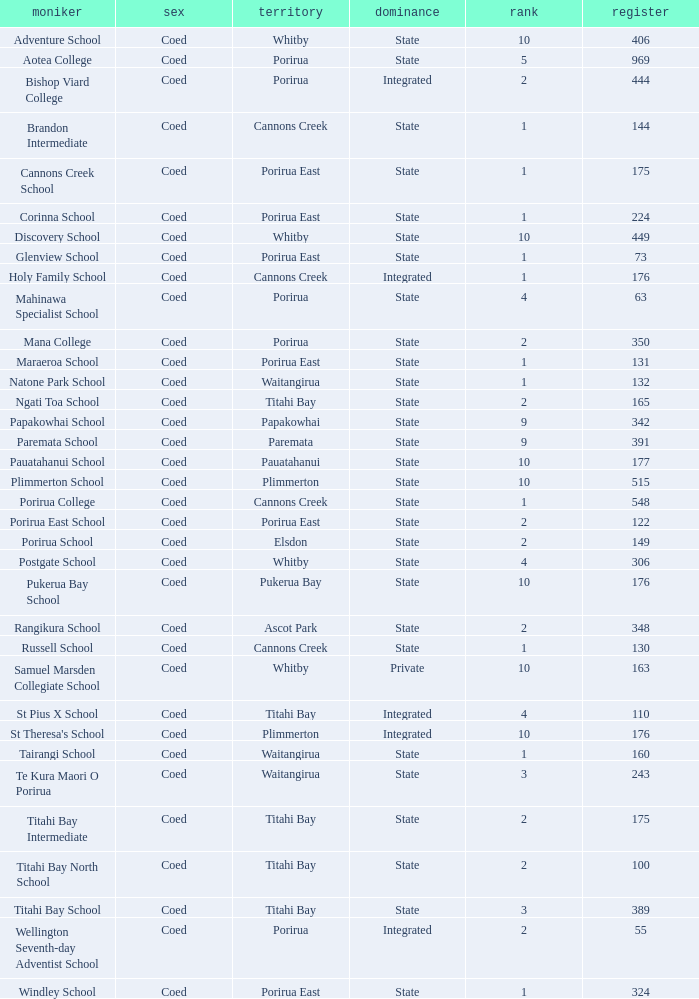What is the roll of Bishop Viard College (An Integrated College), which has a decile larger than 1? 1.0. Give me the full table as a dictionary. {'header': ['moniker', 'sex', 'territory', 'dominance', 'rank', 'register'], 'rows': [['Adventure School', 'Coed', 'Whitby', 'State', '10', '406'], ['Aotea College', 'Coed', 'Porirua', 'State', '5', '969'], ['Bishop Viard College', 'Coed', 'Porirua', 'Integrated', '2', '444'], ['Brandon Intermediate', 'Coed', 'Cannons Creek', 'State', '1', '144'], ['Cannons Creek School', 'Coed', 'Porirua East', 'State', '1', '175'], ['Corinna School', 'Coed', 'Porirua East', 'State', '1', '224'], ['Discovery School', 'Coed', 'Whitby', 'State', '10', '449'], ['Glenview School', 'Coed', 'Porirua East', 'State', '1', '73'], ['Holy Family School', 'Coed', 'Cannons Creek', 'Integrated', '1', '176'], ['Mahinawa Specialist School', 'Coed', 'Porirua', 'State', '4', '63'], ['Mana College', 'Coed', 'Porirua', 'State', '2', '350'], ['Maraeroa School', 'Coed', 'Porirua East', 'State', '1', '131'], ['Natone Park School', 'Coed', 'Waitangirua', 'State', '1', '132'], ['Ngati Toa School', 'Coed', 'Titahi Bay', 'State', '2', '165'], ['Papakowhai School', 'Coed', 'Papakowhai', 'State', '9', '342'], ['Paremata School', 'Coed', 'Paremata', 'State', '9', '391'], ['Pauatahanui School', 'Coed', 'Pauatahanui', 'State', '10', '177'], ['Plimmerton School', 'Coed', 'Plimmerton', 'State', '10', '515'], ['Porirua College', 'Coed', 'Cannons Creek', 'State', '1', '548'], ['Porirua East School', 'Coed', 'Porirua East', 'State', '2', '122'], ['Porirua School', 'Coed', 'Elsdon', 'State', '2', '149'], ['Postgate School', 'Coed', 'Whitby', 'State', '4', '306'], ['Pukerua Bay School', 'Coed', 'Pukerua Bay', 'State', '10', '176'], ['Rangikura School', 'Coed', 'Ascot Park', 'State', '2', '348'], ['Russell School', 'Coed', 'Cannons Creek', 'State', '1', '130'], ['Samuel Marsden Collegiate School', 'Coed', 'Whitby', 'Private', '10', '163'], ['St Pius X School', 'Coed', 'Titahi Bay', 'Integrated', '4', '110'], ["St Theresa's School", 'Coed', 'Plimmerton', 'Integrated', '10', '176'], ['Tairangi School', 'Coed', 'Waitangirua', 'State', '1', '160'], ['Te Kura Maori O Porirua', 'Coed', 'Waitangirua', 'State', '3', '243'], ['Titahi Bay Intermediate', 'Coed', 'Titahi Bay', 'State', '2', '175'], ['Titahi Bay North School', 'Coed', 'Titahi Bay', 'State', '2', '100'], ['Titahi Bay School', 'Coed', 'Titahi Bay', 'State', '3', '389'], ['Wellington Seventh-day Adventist School', 'Coed', 'Porirua', 'Integrated', '2', '55'], ['Windley School', 'Coed', 'Porirua East', 'State', '1', '324']]} 